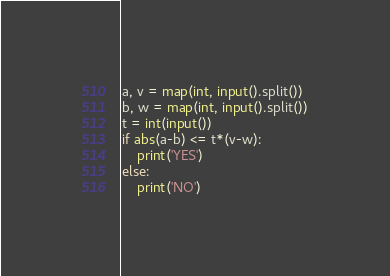<code> <loc_0><loc_0><loc_500><loc_500><_Python_>a, v = map(int, input().split())
b, w = map(int, input().split())
t = int(input())
if abs(a-b) <= t*(v-w):
    print('YES')
else:
    print('NO')</code> 